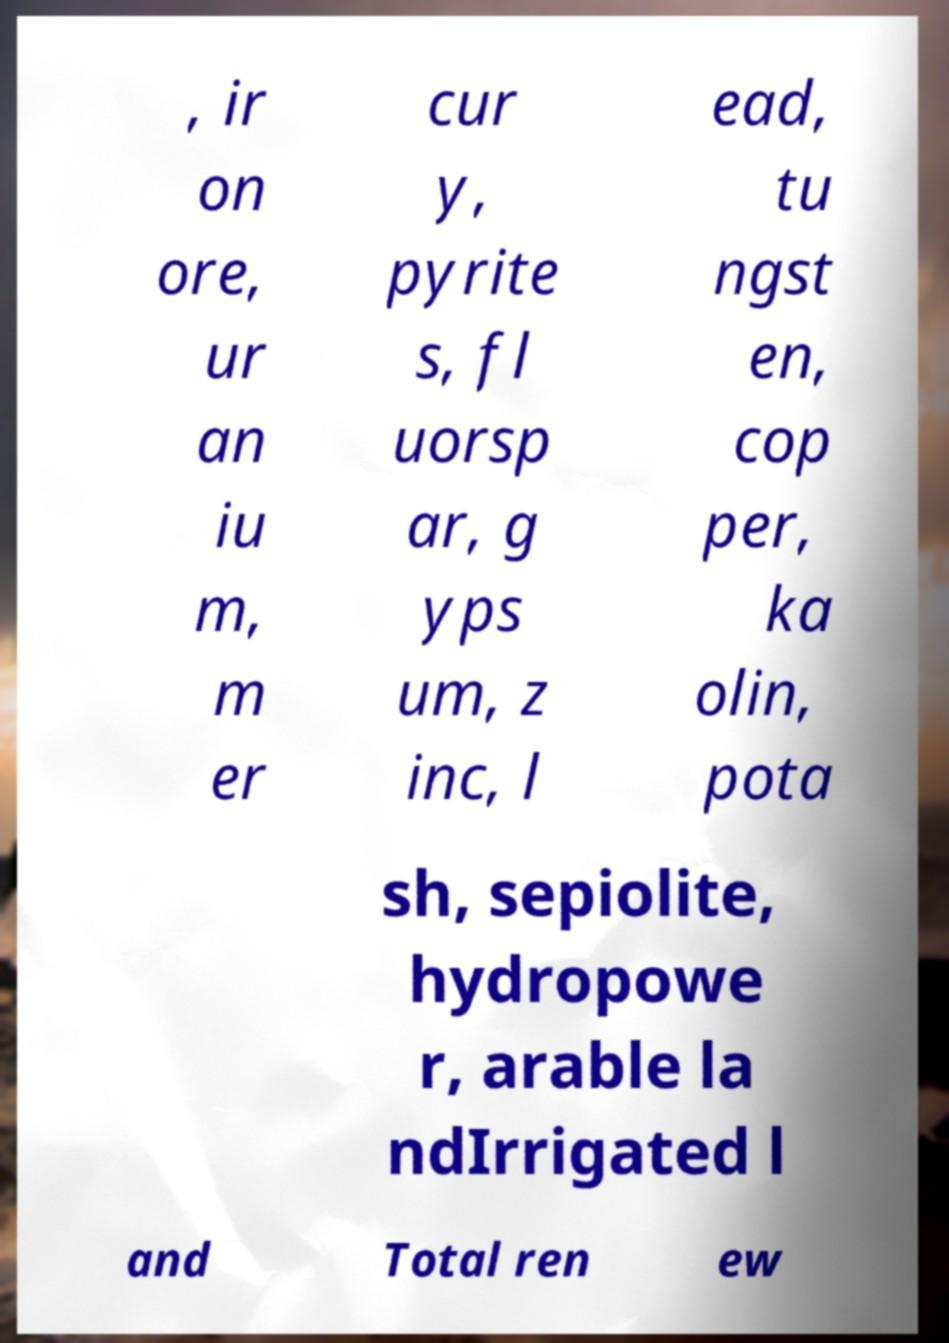Can you read and provide the text displayed in the image?This photo seems to have some interesting text. Can you extract and type it out for me? , ir on ore, ur an iu m, m er cur y, pyrite s, fl uorsp ar, g yps um, z inc, l ead, tu ngst en, cop per, ka olin, pota sh, sepiolite, hydropowe r, arable la ndIrrigated l and Total ren ew 